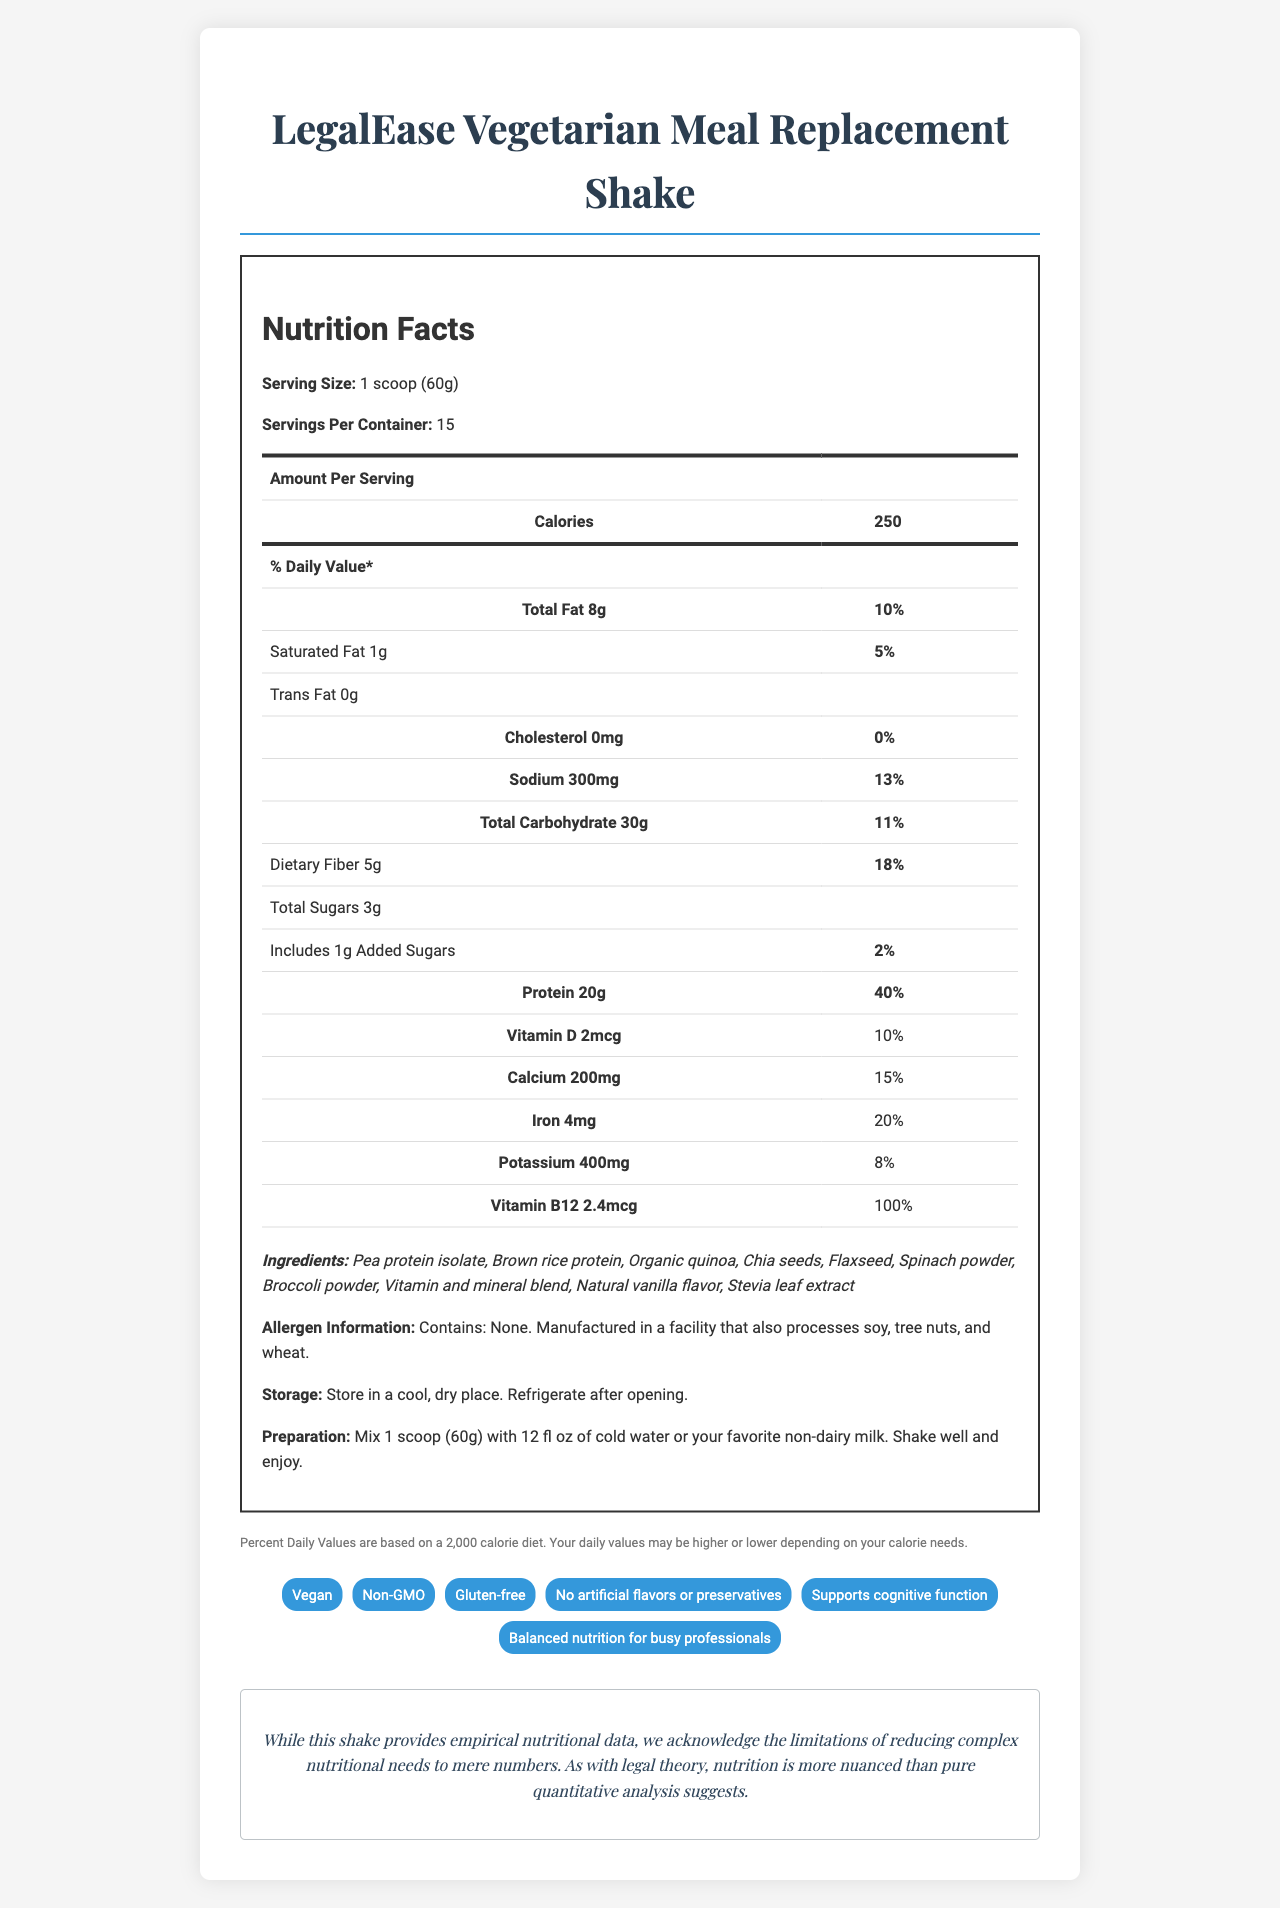what is the serving size for LegalEase Vegetarian Meal Replacement Shake? The serving size is explicitly mentioned as "1 scoop (60g)" in the nutrition facts section of the document.
Answer: 1 scoop (60g) how many servings are there per container? The number of servings per container is listed as 15 in the document.
Answer: 15 what is the amount of protein per serving? The amount of protein per serving is specified as 20g.
Answer: 20g what is the daily value percentage of dietary fiber? The daily value percentage of dietary fiber is given as 18%.
Answer: 18% how much added sugar does each serving contain? Each serving contains 1g of added sugar according to the nutrition facts.
Answer: 1g is this product vegan? (Yes/No) The product claims list includes "Vegan," indicating that the product is suitable for vegan consumers.
Answer: Yes which vitamin or mineral is present at 100% of the daily value?
A. Vitamin D
B. Calcium
C. Iron
D. Vitamin B12 Vitamin B12 is present at 100% of the daily value.
Answer: D how many calories are there per serving? The document states that there are 250 calories per serving.
Answer: 250 what is the total fat content per serving? The total fat content per serving is specified as 8g.
Answer: 8g which ingredient is not listed in the document? 
A. Pea protein isolate
B. Brown rice protein
C. Whey protein
D. Chia seeds Whey protein is not listed among the ingredients.
Answer: C does the product contain any common allergens? The document explicitly notes "Contains: None." indicating that no common allergens are directly in the product, although it is manufactured in a facility that processes soy, tree nuts, and wheat.
Answer: No summarize the main idea of the document. The document detailedly outlines the nutritional profile, ingredients, and claims of the product while emphasizing its benefits for busy professionals, specifically targeting law professors.
Answer: The document provides detailed nutritional information, ingredients list, and product claims for the LegalEase Vegetarian Meal Replacement Shake, aimed at busy law professors. It emphasizes balanced nutrition, plant-based ingredients, and cognitive support with data on vitamins, minerals, and macro-nutrients, along with preparation and storage instructions. what is the amount of sodium per serving and its daily value percentage? The amount of sodium per serving is 300mg, with a daily value percentage of 13%.
Answer: 300mg, 13% how should the product be stored after opening? The storage instructions specify to refrigerate the product after opening.
Answer: Refrigerate after opening. is there enough information on the document to determine the environmental impact of the product? The document does not provide details regarding the environmental impact of the product, such as sourcing, packaging, or production processes.
Answer: Not enough information 